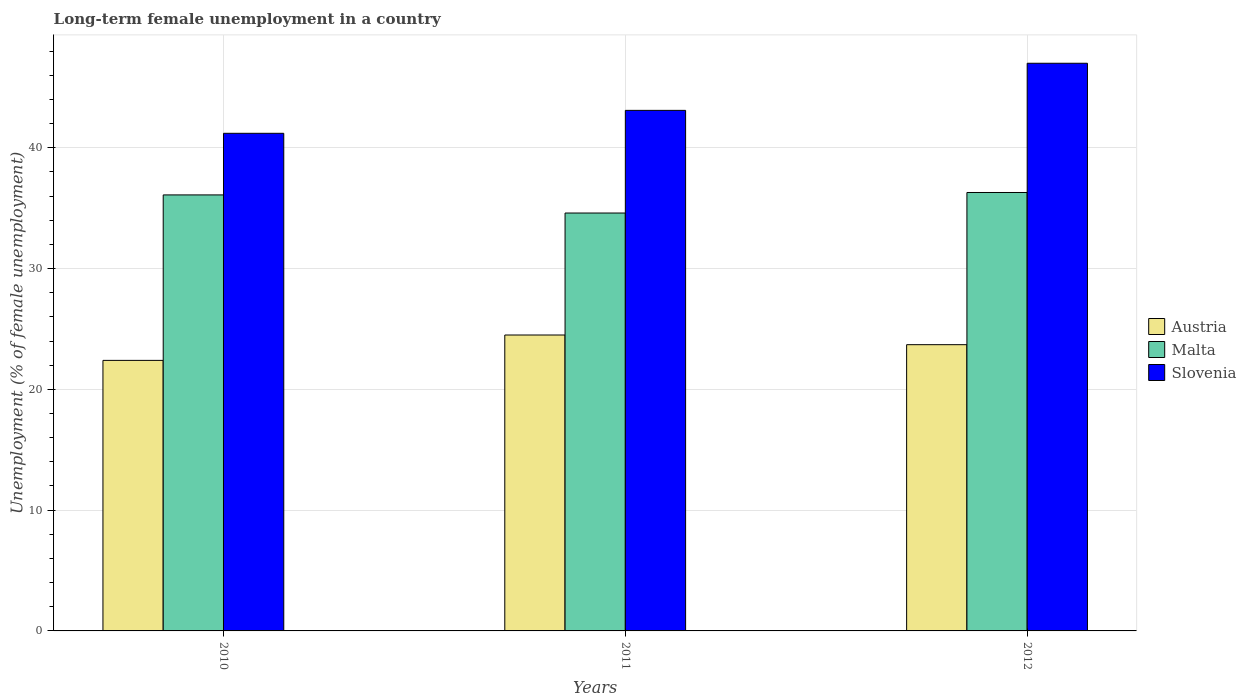How many different coloured bars are there?
Your response must be concise. 3. How many groups of bars are there?
Provide a short and direct response. 3. What is the percentage of long-term unemployed female population in Austria in 2011?
Offer a very short reply. 24.5. Across all years, what is the maximum percentage of long-term unemployed female population in Malta?
Offer a very short reply. 36.3. Across all years, what is the minimum percentage of long-term unemployed female population in Slovenia?
Make the answer very short. 41.2. In which year was the percentage of long-term unemployed female population in Austria maximum?
Your answer should be compact. 2011. What is the total percentage of long-term unemployed female population in Austria in the graph?
Your answer should be very brief. 70.6. What is the difference between the percentage of long-term unemployed female population in Austria in 2010 and that in 2012?
Your answer should be very brief. -1.3. What is the difference between the percentage of long-term unemployed female population in Slovenia in 2011 and the percentage of long-term unemployed female population in Malta in 2010?
Your answer should be compact. 7. What is the average percentage of long-term unemployed female population in Malta per year?
Make the answer very short. 35.67. In the year 2011, what is the difference between the percentage of long-term unemployed female population in Austria and percentage of long-term unemployed female population in Slovenia?
Provide a short and direct response. -18.6. What is the ratio of the percentage of long-term unemployed female population in Malta in 2010 to that in 2011?
Offer a very short reply. 1.04. Is the difference between the percentage of long-term unemployed female population in Austria in 2010 and 2012 greater than the difference between the percentage of long-term unemployed female population in Slovenia in 2010 and 2012?
Provide a succinct answer. Yes. What is the difference between the highest and the second highest percentage of long-term unemployed female population in Slovenia?
Your answer should be very brief. 3.9. What is the difference between the highest and the lowest percentage of long-term unemployed female population in Austria?
Your answer should be compact. 2.1. What does the 3rd bar from the left in 2012 represents?
Your response must be concise. Slovenia. What does the 1st bar from the right in 2010 represents?
Your answer should be very brief. Slovenia. Is it the case that in every year, the sum of the percentage of long-term unemployed female population in Slovenia and percentage of long-term unemployed female population in Austria is greater than the percentage of long-term unemployed female population in Malta?
Your answer should be compact. Yes. Are all the bars in the graph horizontal?
Keep it short and to the point. No. What is the difference between two consecutive major ticks on the Y-axis?
Your answer should be very brief. 10. Are the values on the major ticks of Y-axis written in scientific E-notation?
Make the answer very short. No. Does the graph contain any zero values?
Ensure brevity in your answer.  No. Where does the legend appear in the graph?
Provide a succinct answer. Center right. How many legend labels are there?
Your answer should be very brief. 3. What is the title of the graph?
Your response must be concise. Long-term female unemployment in a country. What is the label or title of the X-axis?
Offer a very short reply. Years. What is the label or title of the Y-axis?
Offer a terse response. Unemployment (% of female unemployment). What is the Unemployment (% of female unemployment) in Austria in 2010?
Provide a short and direct response. 22.4. What is the Unemployment (% of female unemployment) in Malta in 2010?
Provide a short and direct response. 36.1. What is the Unemployment (% of female unemployment) in Slovenia in 2010?
Your response must be concise. 41.2. What is the Unemployment (% of female unemployment) in Malta in 2011?
Offer a very short reply. 34.6. What is the Unemployment (% of female unemployment) in Slovenia in 2011?
Offer a terse response. 43.1. What is the Unemployment (% of female unemployment) in Austria in 2012?
Your answer should be very brief. 23.7. What is the Unemployment (% of female unemployment) of Malta in 2012?
Provide a succinct answer. 36.3. What is the Unemployment (% of female unemployment) of Slovenia in 2012?
Ensure brevity in your answer.  47. Across all years, what is the maximum Unemployment (% of female unemployment) of Malta?
Give a very brief answer. 36.3. Across all years, what is the minimum Unemployment (% of female unemployment) in Austria?
Give a very brief answer. 22.4. Across all years, what is the minimum Unemployment (% of female unemployment) in Malta?
Provide a short and direct response. 34.6. Across all years, what is the minimum Unemployment (% of female unemployment) in Slovenia?
Your response must be concise. 41.2. What is the total Unemployment (% of female unemployment) in Austria in the graph?
Give a very brief answer. 70.6. What is the total Unemployment (% of female unemployment) in Malta in the graph?
Ensure brevity in your answer.  107. What is the total Unemployment (% of female unemployment) in Slovenia in the graph?
Ensure brevity in your answer.  131.3. What is the difference between the Unemployment (% of female unemployment) in Austria in 2010 and that in 2011?
Make the answer very short. -2.1. What is the difference between the Unemployment (% of female unemployment) of Malta in 2010 and that in 2011?
Offer a terse response. 1.5. What is the difference between the Unemployment (% of female unemployment) in Slovenia in 2010 and that in 2011?
Provide a succinct answer. -1.9. What is the difference between the Unemployment (% of female unemployment) in Austria in 2010 and that in 2012?
Your response must be concise. -1.3. What is the difference between the Unemployment (% of female unemployment) in Austria in 2011 and that in 2012?
Keep it short and to the point. 0.8. What is the difference between the Unemployment (% of female unemployment) of Austria in 2010 and the Unemployment (% of female unemployment) of Malta in 2011?
Offer a very short reply. -12.2. What is the difference between the Unemployment (% of female unemployment) in Austria in 2010 and the Unemployment (% of female unemployment) in Slovenia in 2011?
Provide a short and direct response. -20.7. What is the difference between the Unemployment (% of female unemployment) in Austria in 2010 and the Unemployment (% of female unemployment) in Malta in 2012?
Your answer should be very brief. -13.9. What is the difference between the Unemployment (% of female unemployment) of Austria in 2010 and the Unemployment (% of female unemployment) of Slovenia in 2012?
Offer a terse response. -24.6. What is the difference between the Unemployment (% of female unemployment) in Malta in 2010 and the Unemployment (% of female unemployment) in Slovenia in 2012?
Make the answer very short. -10.9. What is the difference between the Unemployment (% of female unemployment) of Austria in 2011 and the Unemployment (% of female unemployment) of Malta in 2012?
Make the answer very short. -11.8. What is the difference between the Unemployment (% of female unemployment) of Austria in 2011 and the Unemployment (% of female unemployment) of Slovenia in 2012?
Your response must be concise. -22.5. What is the difference between the Unemployment (% of female unemployment) in Malta in 2011 and the Unemployment (% of female unemployment) in Slovenia in 2012?
Offer a terse response. -12.4. What is the average Unemployment (% of female unemployment) of Austria per year?
Ensure brevity in your answer.  23.53. What is the average Unemployment (% of female unemployment) in Malta per year?
Your response must be concise. 35.67. What is the average Unemployment (% of female unemployment) of Slovenia per year?
Keep it short and to the point. 43.77. In the year 2010, what is the difference between the Unemployment (% of female unemployment) in Austria and Unemployment (% of female unemployment) in Malta?
Provide a succinct answer. -13.7. In the year 2010, what is the difference between the Unemployment (% of female unemployment) of Austria and Unemployment (% of female unemployment) of Slovenia?
Ensure brevity in your answer.  -18.8. In the year 2011, what is the difference between the Unemployment (% of female unemployment) of Austria and Unemployment (% of female unemployment) of Slovenia?
Your response must be concise. -18.6. In the year 2012, what is the difference between the Unemployment (% of female unemployment) in Austria and Unemployment (% of female unemployment) in Malta?
Make the answer very short. -12.6. In the year 2012, what is the difference between the Unemployment (% of female unemployment) in Austria and Unemployment (% of female unemployment) in Slovenia?
Your answer should be compact. -23.3. In the year 2012, what is the difference between the Unemployment (% of female unemployment) of Malta and Unemployment (% of female unemployment) of Slovenia?
Your response must be concise. -10.7. What is the ratio of the Unemployment (% of female unemployment) of Austria in 2010 to that in 2011?
Ensure brevity in your answer.  0.91. What is the ratio of the Unemployment (% of female unemployment) of Malta in 2010 to that in 2011?
Make the answer very short. 1.04. What is the ratio of the Unemployment (% of female unemployment) of Slovenia in 2010 to that in 2011?
Make the answer very short. 0.96. What is the ratio of the Unemployment (% of female unemployment) of Austria in 2010 to that in 2012?
Your answer should be very brief. 0.95. What is the ratio of the Unemployment (% of female unemployment) in Slovenia in 2010 to that in 2012?
Give a very brief answer. 0.88. What is the ratio of the Unemployment (% of female unemployment) in Austria in 2011 to that in 2012?
Provide a short and direct response. 1.03. What is the ratio of the Unemployment (% of female unemployment) in Malta in 2011 to that in 2012?
Make the answer very short. 0.95. What is the ratio of the Unemployment (% of female unemployment) in Slovenia in 2011 to that in 2012?
Provide a succinct answer. 0.92. What is the difference between the highest and the second highest Unemployment (% of female unemployment) in Slovenia?
Offer a terse response. 3.9. What is the difference between the highest and the lowest Unemployment (% of female unemployment) of Austria?
Your response must be concise. 2.1. What is the difference between the highest and the lowest Unemployment (% of female unemployment) of Malta?
Make the answer very short. 1.7. 